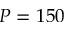<formula> <loc_0><loc_0><loc_500><loc_500>P = 1 5 0</formula> 